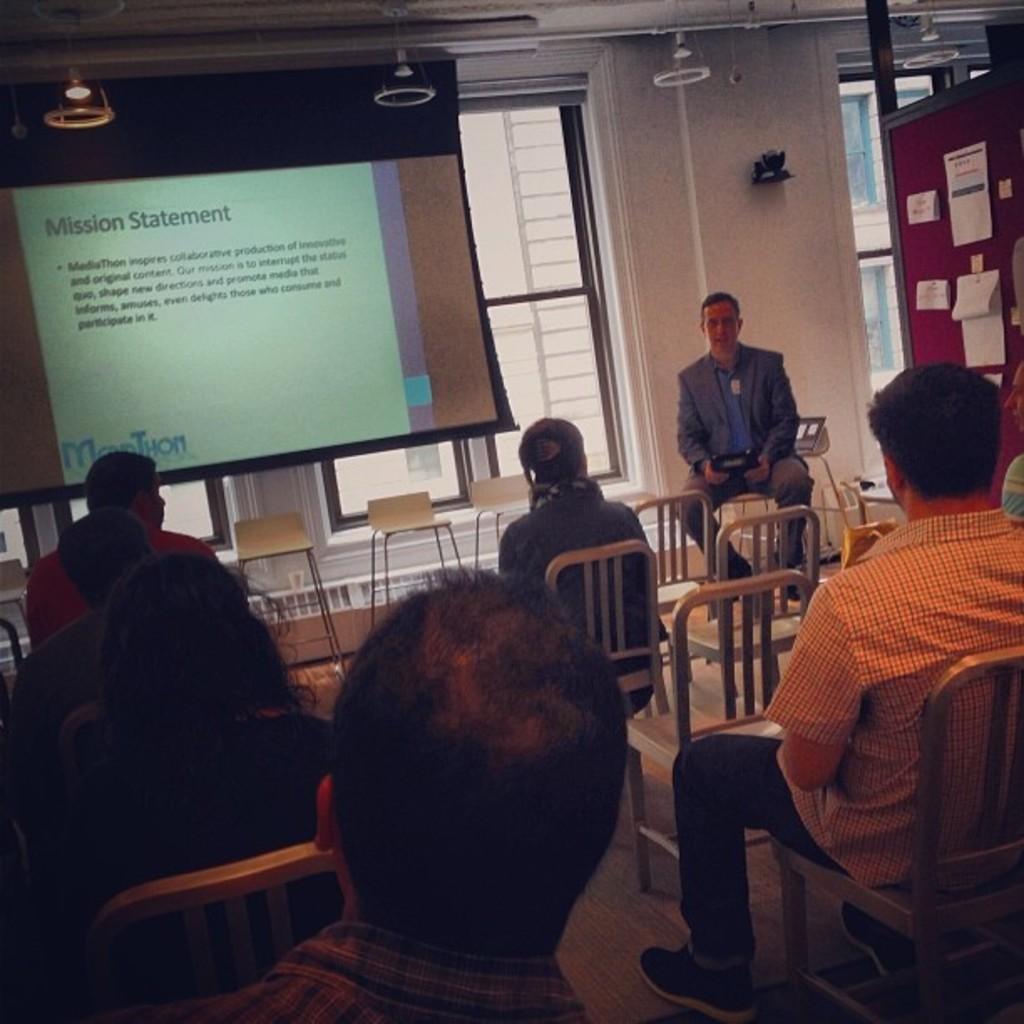Can you describe this image briefly? there are group of people sitting in chairs and listening to the lecture of the opposite man and there is a big screen in the room. 